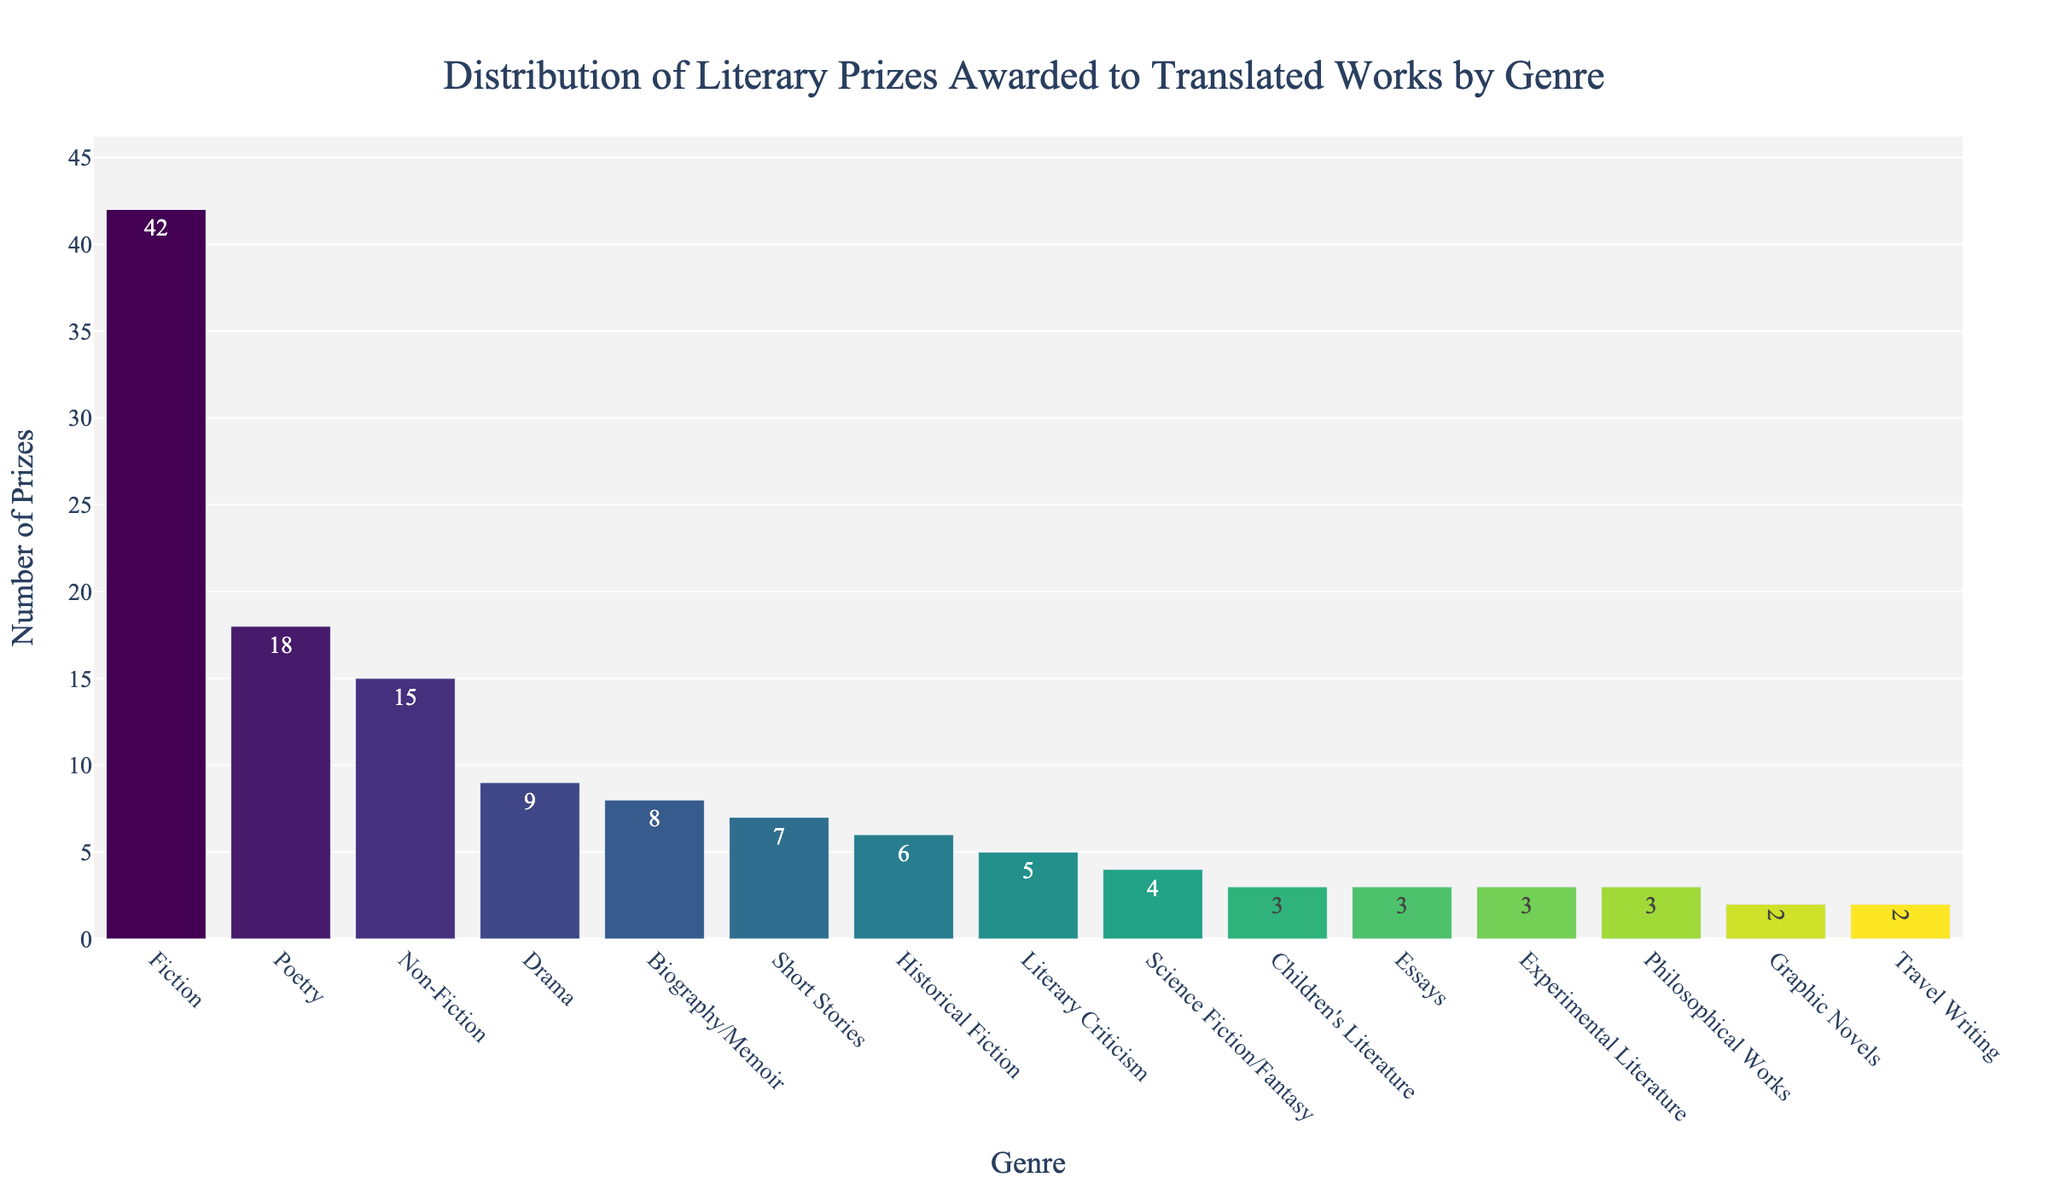Which genre has the highest number of literary prizes? When looking at the bar chart, the tallest bar represents the genre with the highest number of prizes won. The bar for "Fiction" is the tallest.
Answer: Fiction How many more literary prizes have been awarded to Fiction than to Drama? To find the difference, look at the number of prizes for Fiction and Drama. Fiction has 42, and Drama has 9. Subtract 9 from 42: 42 - 9 = 33.
Answer: 33 What is the combined total number of literary prizes for Poetry, Non-Fiction, and Drama? Sum the number of prizes for Poetry (18), Non-Fiction (15), and Drama (9). 18 + 15 + 9 = 42.
Answer: 42 Which genre has the least number of literary prizes? The shortest bar in the chart represents the genre with the least prizes. "Graphic Novels" has the shortest bar with 2 prizes.
Answer: Graphic Novels Is the number of prizes for Poetry greater than the number of prizes for Short Stories and Literary Criticism combined? First, sum the prizes for Short Stories (7) and Literary Criticism (5): 7 + 5 = 12. Poetry has 18 prizes, which is greater than 12.
Answer: Yes What is the difference in the number of prizes between the genre with the highest and the genre with the lowest prizes? Find the differences by subtracting the lowest value (Graphic Novels, 2) from the highest value (Fiction, 42). 42 - 2 = 40.
Answer: 40 Which genres have been awarded exactly three literary prizes? Identify the bars with the height corresponding to 3 prizes. These are "Children's Literature," "Essays," "Experimental Literature," and "Philosophical Works."
Answer: Children's Literature, Essays, Experimental Literature, Philosophical Works By how much does the number of prizes for Historical Fiction differ from that of Science Fiction/Fantasy? Subtract the number of prizes for Science Fiction/Fantasy (4) from that for Historical Fiction (6). 6 - 4 = 2.
Answer: 2 What fraction of the total number of prizes does Fiction represent? First, sum the total number of prizes. Total = 42 (Fiction) + 18 + 15 + 9 + 7 + 5 + 8 + 3 + 4 + 6 + 3 + 2 + 3 + 2 + 3 = 130. Now, calculate the fraction for Fiction: 42/130. Simplify to 21/65.
Answer: 21/65 If the prizes for Poetry and Non-Fiction were equalized to their average, what would be the new count for each genre? Calculate the average of Poetry (18) and Non-Fiction (15). (18 + 15) / 2 = 16.5. Round to the nearest whole number if needed. Both genres would have 16.5 prizes.
Answer: 16.5 